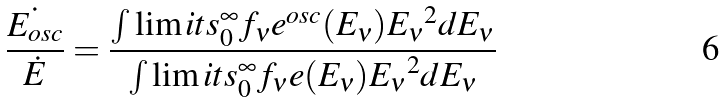<formula> <loc_0><loc_0><loc_500><loc_500>\frac { \dot { E _ { o s c } } } { \dot { E } } = \frac { \int \lim i t s _ { 0 } ^ { \infty } f _ { \nu } e ^ { o s c } ( E _ { \nu } ) { E _ { \nu } } ^ { 2 } d E _ { \nu } } { \int \lim i t s _ { 0 } ^ { \infty } f _ { \nu } e ( E _ { \nu } ) { E _ { \nu } } ^ { 2 } d E _ { \nu } }</formula> 